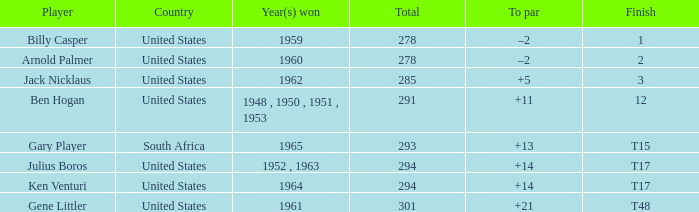Would you be able to parse every entry in this table? {'header': ['Player', 'Country', 'Year(s) won', 'Total', 'To par', 'Finish'], 'rows': [['Billy Casper', 'United States', '1959', '278', '–2', '1'], ['Arnold Palmer', 'United States', '1960', '278', '–2', '2'], ['Jack Nicklaus', 'United States', '1962', '285', '+5', '3'], ['Ben Hogan', 'United States', '1948 , 1950 , 1951 , 1953', '291', '+11', '12'], ['Gary Player', 'South Africa', '1965', '293', '+13', 'T15'], ['Julius Boros', 'United States', '1952 , 1963', '294', '+14', 'T17'], ['Ken Venturi', 'United States', '1964', '294', '+14', 'T17'], ['Gene Littler', 'United States', '1961', '301', '+21', 'T48']]} In which country was the year of winning "1962"? United States. 